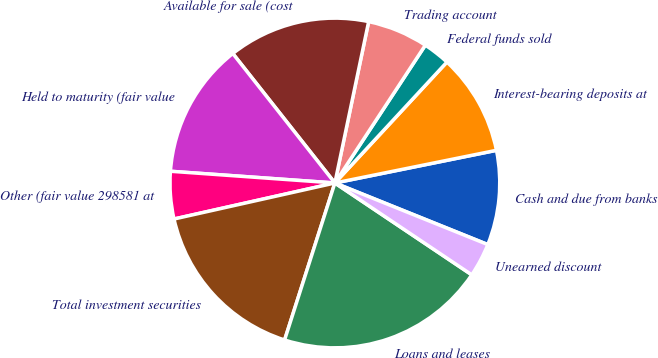<chart> <loc_0><loc_0><loc_500><loc_500><pie_chart><fcel>Cash and due from banks<fcel>Interest-bearing deposits at<fcel>Federal funds sold<fcel>Trading account<fcel>Available for sale (cost<fcel>Held to maturity (fair value<fcel>Other (fair value 298581 at<fcel>Total investment securities<fcel>Loans and leases<fcel>Unearned discount<nl><fcel>9.27%<fcel>9.93%<fcel>2.65%<fcel>5.96%<fcel>13.91%<fcel>13.24%<fcel>4.64%<fcel>16.56%<fcel>20.53%<fcel>3.31%<nl></chart> 